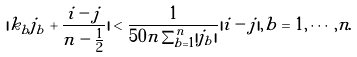<formula> <loc_0><loc_0><loc_500><loc_500>| k _ { b } j _ { b } + \frac { i - j } { n - \frac { 1 } { 2 } } | < \frac { 1 } { 5 0 n \sum _ { b = 1 } ^ { n } | j _ { b } | } | i - j | , b = 1 , \cdots , n .</formula> 